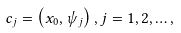Convert formula to latex. <formula><loc_0><loc_0><loc_500><loc_500>c _ { j } = \left ( x _ { 0 } , \psi _ { j } \right ) , j = 1 , 2 , \dots ,</formula> 